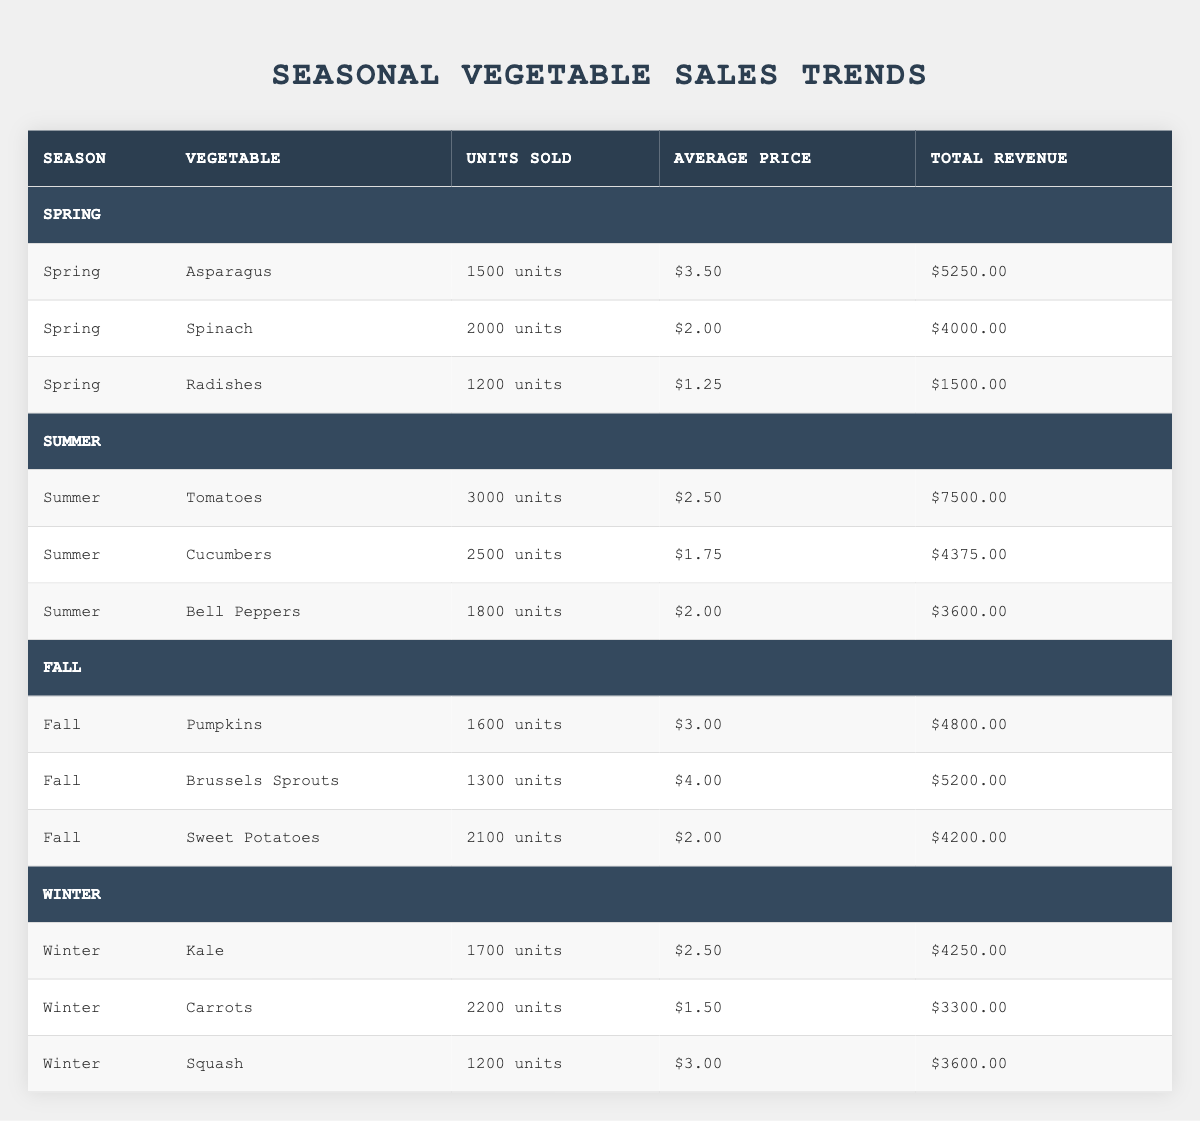What vegetable sold the most units in Summer? In the Summer section, Tomatoes are listed with 3000 units sold, which is higher than Cucumbers (2500) and Bell Peppers (1800). Thus, Tomatoes had the highest sales in that season.
Answer: Tomatoes What is the total revenue generated by Spinach? The revenue for Spinach is indicated as $4000 in the table, which corresponds directly to the value listed next to Spinach under the Total Revenue column.
Answer: $4000 Which season has the least total revenue? The total revenues for each season are: Spring ($10750), Summer ($11225), Fall ($12400), and Winter ($11150). By comparing these, Spring has the least total revenue of $10750.
Answer: Spring How many units of Brussels Sprouts and Sweet Potatoes were sold in Fall combined? Brussels Sprouts sold 1300 units and Sweet Potatoes sold 2100 units. Adding these gives 1300 + 2100 = 3400 units combined for Fall.
Answer: 3400 Is the average price of Cucumbers higher than that of Carrots? The average price for Cucumbers is $1.75 and for Carrots it’s $1.50. Since $1.75 is greater than $1.50, the statement is true.
Answer: Yes What is the average total revenue per season across all seasons? The total revenue for all seasons combined is $10750 (Spring) + $11225 (Summer) + $12400 (Fall) + $11150 (Winter) = $45525. There are 4 seasons, so the average is $45525 / 4 = $11381.25.
Answer: $11381.25 Which vegetable had the highest average price per unit and what is that price? Comparing the average prices in the table: Asparagus ($3.50), Brussels Sprouts ($4.00), and Squash ($3.00), Brussels Sprouts has the highest average price of $4.00.
Answer: $4.00 How many more units of Kale were sold compared to Radishes? Kale sold 1700 units and Radishes sold 1200 units. The difference is 1700 - 1200 = 500 more units.
Answer: 500 What was the total revenue from Winter vegetables? The revenue from individual Winter vegetables is Kale ($4250), Carrots ($3300), and Squash ($3600). Adding these gives $4250 + $3300 + $3600 = $11150 total revenue for Winter.
Answer: $11150 Does any vegetable in Spring generate revenue higher than $5000? The total revenues for Spring vegetables are $5250 (Asparagus), $4000 (Spinach), and $1500 (Radishes). Asparagus is the only vegetable exceeding $5000, so the statement is true.
Answer: Yes 